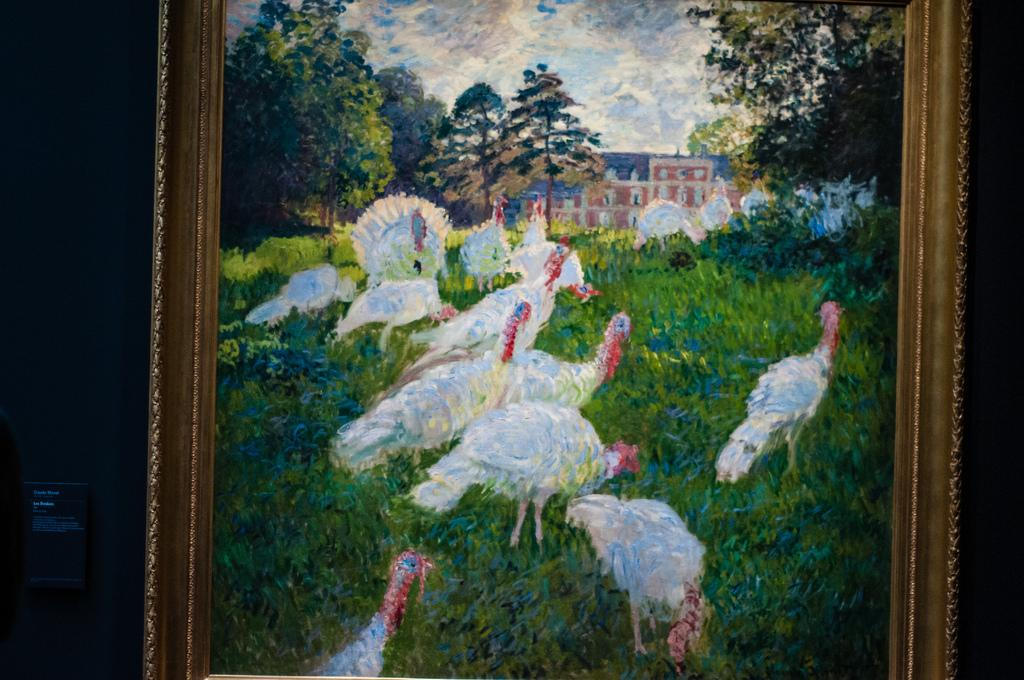What is the main subject of the image? There is a portrait in the image. What can be seen in the portrait? There are hens on the grassland and trees in the portrait. Are there any structures visible in the portrait? Yes, there is a building in the portrait. What type of bag is being used to carry the yarn in the image? There is no bag or yarn present in the image; it features a portrait with hens, grassland, trees, and a building. 